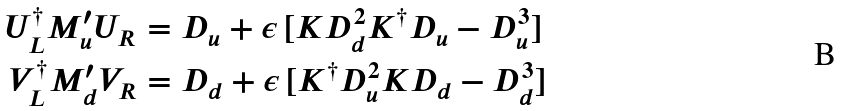<formula> <loc_0><loc_0><loc_500><loc_500>U _ { L } ^ { \dag } M ^ { \prime } _ { u } U _ { R } & = D _ { u } + \epsilon \, [ K D _ { d } ^ { 2 } K ^ { \dag } D _ { u } - D _ { u } ^ { 3 } ] \\ V _ { L } ^ { \dag } M ^ { \prime } _ { d } V _ { R } & = D _ { d } + \epsilon \, [ K ^ { \dag } D _ { u } ^ { 2 } K D _ { d } - D _ { d } ^ { 3 } ]</formula> 